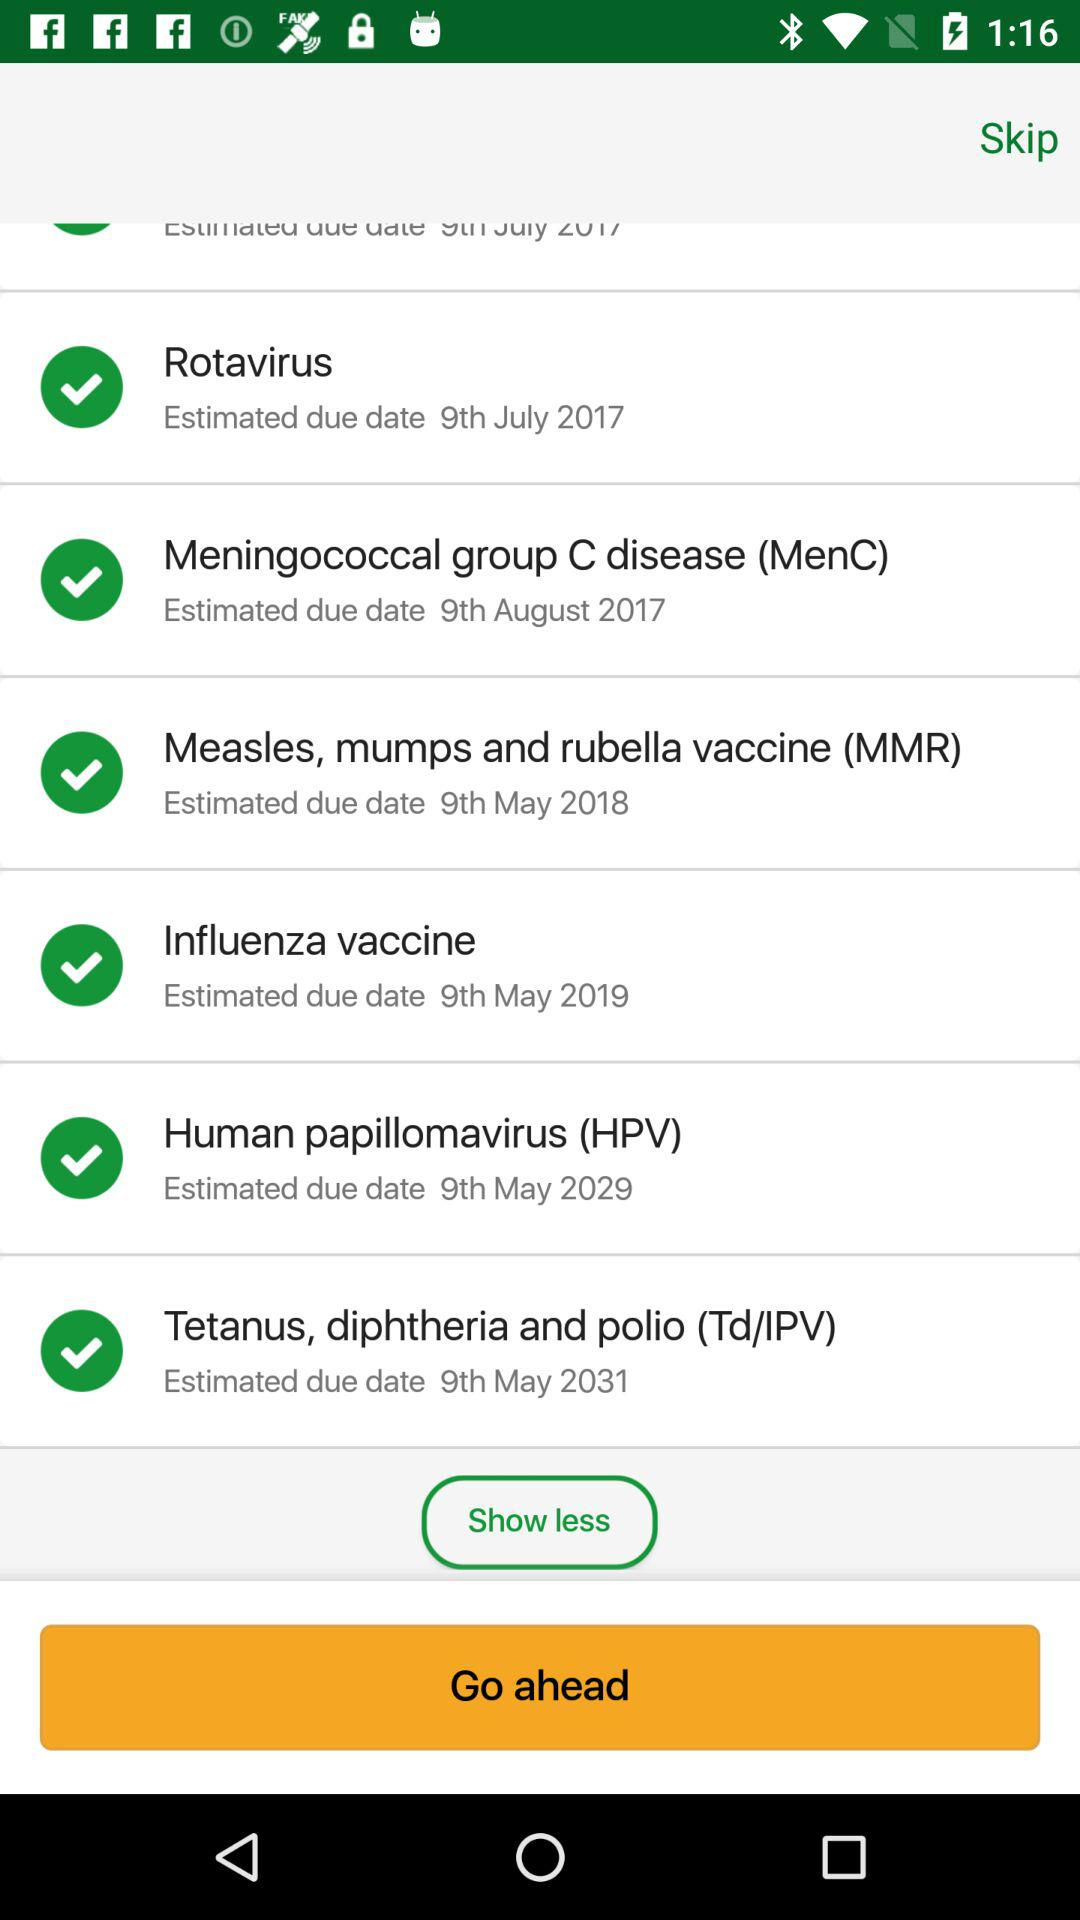What is the estimated due date of "Rotavirus"? The estimated due date of "Rotavirus" is July 9, 2017. 